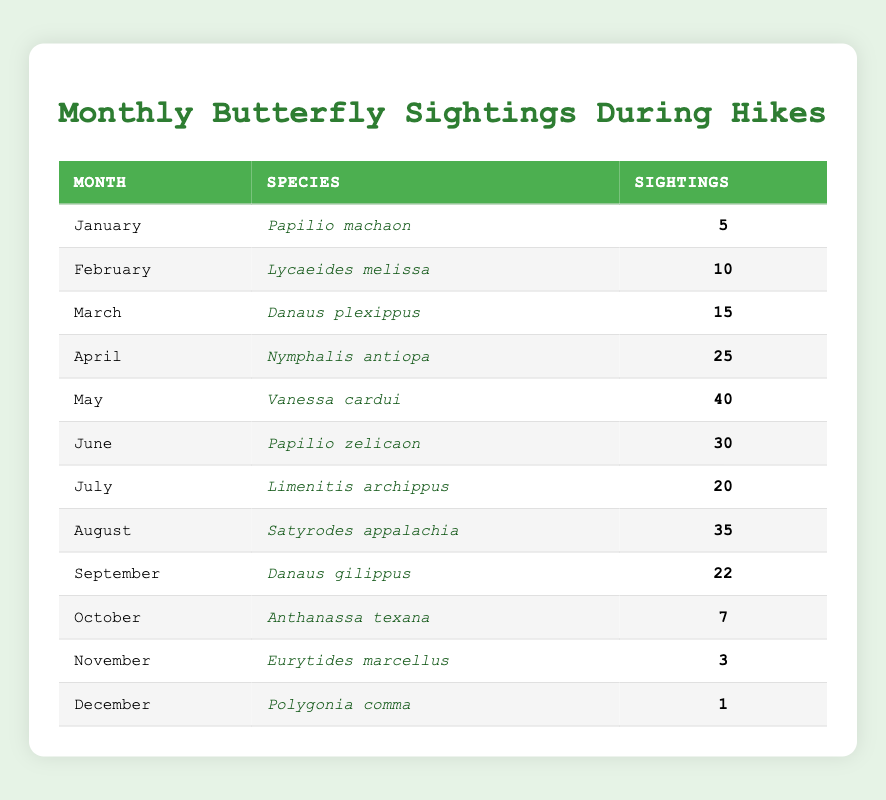What butterfly species had the highest sightings? Looking at the table, the month of May shows the highest sightings with 40. The corresponding species for that month is Vanessa cardui.
Answer: Vanessa cardui How many butterfly sightings were reported in November? By checking the November row in the table, there are 3 sightings recorded for the species Eurytides marcellus.
Answer: 3 Which month had the lowest butterfly sightings? The month of December has the lowest sightings, with only 1 recorded sighting for the species Polygonia comma.
Answer: December What is the total number of butterfly sightings from March to August? Adding the sightings from March (15), April (25), May (40), June (30), July (20), and August (35) gives (15 + 25 + 40 + 30 + 20 + 35) = 165.
Answer: 165 How many butterfly species had more than 20 sightings? From the table, the species with more than 20 sightings are Nymphalis antiopa (25), Vanessa cardui (40), Papilio zelicaon (30), Satyrodes appalachia (35), and Danaus gilippus (22), totaling 5 species.
Answer: 5 Is there any month with more than 30 sightings? Yes, May with 40 and June with 30 have more than 30 sightings.
Answer: Yes What is the average number of butterfly sightings from January to June? Summing the sightings from January (5), February (10), March (15), April (25), May (40), and June (30) gives 95, and dividing by 6 months gives an average of 95/6 ≈ 15.83.
Answer: Approximately 15.83 Which month had more sightings, July or October? July had 20 sightings while October had 7 sightings, making July the month with more sightings.
Answer: July How many months had fewer than 10 sightings? In the table, the months with fewer than 10 sightings are November (3) and December (1), totaling 2 months.
Answer: 2 Subtract the sightings of the species in January from those in May. What is the result? January has 5 sightings and May has 40, so subtracting gives 40 - 5 = 35.
Answer: 35 